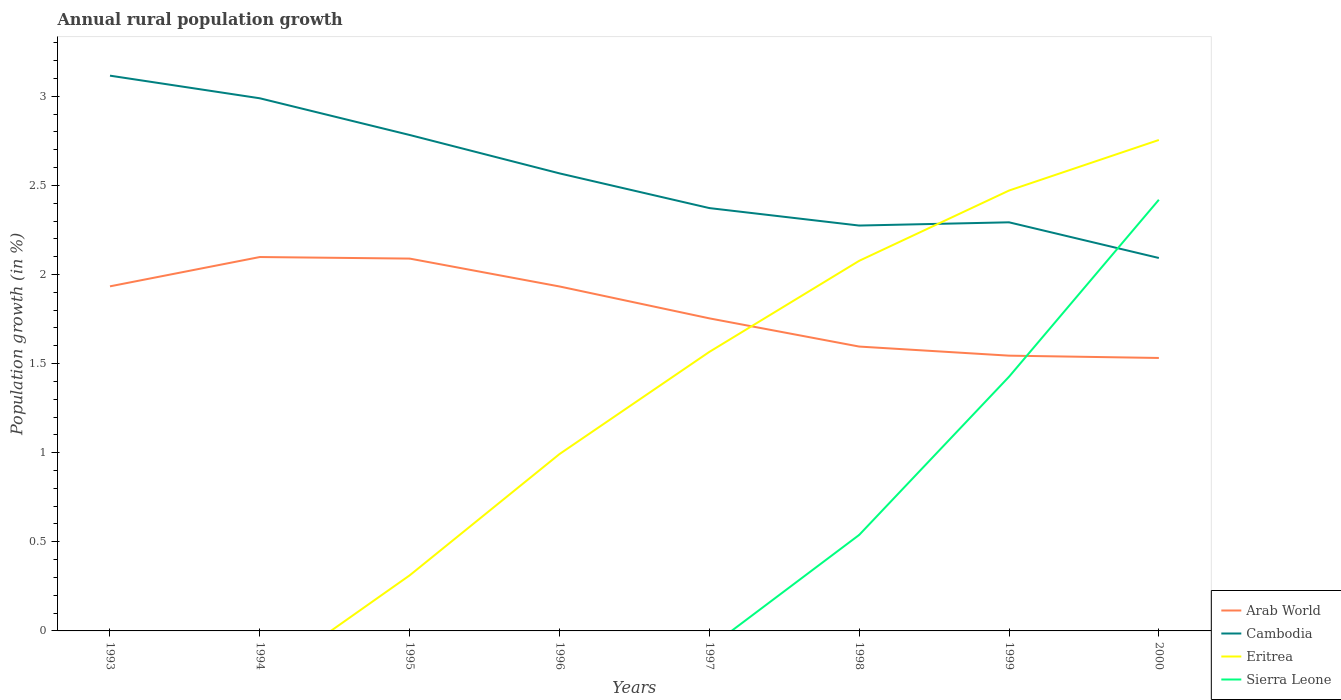How many different coloured lines are there?
Your answer should be compact. 4. Does the line corresponding to Arab World intersect with the line corresponding to Sierra Leone?
Your response must be concise. Yes. Is the number of lines equal to the number of legend labels?
Keep it short and to the point. No. Across all years, what is the maximum percentage of rural population growth in Sierra Leone?
Your answer should be very brief. 0. What is the total percentage of rural population growth in Arab World in the graph?
Your answer should be compact. 0.05. What is the difference between the highest and the second highest percentage of rural population growth in Sierra Leone?
Your response must be concise. 2.42. Is the percentage of rural population growth in Arab World strictly greater than the percentage of rural population growth in Sierra Leone over the years?
Give a very brief answer. No. How many years are there in the graph?
Make the answer very short. 8. What is the difference between two consecutive major ticks on the Y-axis?
Make the answer very short. 0.5. Does the graph contain any zero values?
Make the answer very short. Yes. Does the graph contain grids?
Keep it short and to the point. No. How many legend labels are there?
Give a very brief answer. 4. How are the legend labels stacked?
Your response must be concise. Vertical. What is the title of the graph?
Your answer should be compact. Annual rural population growth. What is the label or title of the Y-axis?
Ensure brevity in your answer.  Population growth (in %). What is the Population growth (in %) in Arab World in 1993?
Offer a very short reply. 1.93. What is the Population growth (in %) of Cambodia in 1993?
Provide a succinct answer. 3.12. What is the Population growth (in %) of Eritrea in 1993?
Your response must be concise. 0. What is the Population growth (in %) in Arab World in 1994?
Ensure brevity in your answer.  2.1. What is the Population growth (in %) of Cambodia in 1994?
Offer a terse response. 2.99. What is the Population growth (in %) in Sierra Leone in 1994?
Give a very brief answer. 0. What is the Population growth (in %) of Arab World in 1995?
Offer a terse response. 2.09. What is the Population growth (in %) of Cambodia in 1995?
Provide a short and direct response. 2.78. What is the Population growth (in %) of Eritrea in 1995?
Provide a short and direct response. 0.31. What is the Population growth (in %) of Sierra Leone in 1995?
Provide a succinct answer. 0. What is the Population growth (in %) in Arab World in 1996?
Keep it short and to the point. 1.93. What is the Population growth (in %) in Cambodia in 1996?
Give a very brief answer. 2.57. What is the Population growth (in %) in Eritrea in 1996?
Ensure brevity in your answer.  0.99. What is the Population growth (in %) of Arab World in 1997?
Provide a succinct answer. 1.75. What is the Population growth (in %) of Cambodia in 1997?
Give a very brief answer. 2.37. What is the Population growth (in %) in Eritrea in 1997?
Provide a succinct answer. 1.57. What is the Population growth (in %) of Arab World in 1998?
Provide a short and direct response. 1.6. What is the Population growth (in %) of Cambodia in 1998?
Make the answer very short. 2.27. What is the Population growth (in %) in Eritrea in 1998?
Make the answer very short. 2.08. What is the Population growth (in %) of Sierra Leone in 1998?
Offer a terse response. 0.54. What is the Population growth (in %) of Arab World in 1999?
Ensure brevity in your answer.  1.54. What is the Population growth (in %) of Cambodia in 1999?
Offer a terse response. 2.29. What is the Population growth (in %) of Eritrea in 1999?
Provide a succinct answer. 2.47. What is the Population growth (in %) in Sierra Leone in 1999?
Offer a very short reply. 1.43. What is the Population growth (in %) in Arab World in 2000?
Offer a very short reply. 1.53. What is the Population growth (in %) of Cambodia in 2000?
Offer a very short reply. 2.09. What is the Population growth (in %) in Eritrea in 2000?
Provide a short and direct response. 2.75. What is the Population growth (in %) of Sierra Leone in 2000?
Provide a succinct answer. 2.42. Across all years, what is the maximum Population growth (in %) of Arab World?
Offer a very short reply. 2.1. Across all years, what is the maximum Population growth (in %) of Cambodia?
Your answer should be compact. 3.12. Across all years, what is the maximum Population growth (in %) of Eritrea?
Offer a very short reply. 2.75. Across all years, what is the maximum Population growth (in %) of Sierra Leone?
Ensure brevity in your answer.  2.42. Across all years, what is the minimum Population growth (in %) in Arab World?
Provide a succinct answer. 1.53. Across all years, what is the minimum Population growth (in %) of Cambodia?
Provide a succinct answer. 2.09. Across all years, what is the minimum Population growth (in %) of Eritrea?
Make the answer very short. 0. Across all years, what is the minimum Population growth (in %) in Sierra Leone?
Your answer should be compact. 0. What is the total Population growth (in %) of Arab World in the graph?
Ensure brevity in your answer.  14.48. What is the total Population growth (in %) of Cambodia in the graph?
Offer a terse response. 20.49. What is the total Population growth (in %) of Eritrea in the graph?
Make the answer very short. 10.17. What is the total Population growth (in %) of Sierra Leone in the graph?
Offer a terse response. 4.38. What is the difference between the Population growth (in %) of Arab World in 1993 and that in 1994?
Provide a succinct answer. -0.16. What is the difference between the Population growth (in %) of Cambodia in 1993 and that in 1994?
Offer a very short reply. 0.13. What is the difference between the Population growth (in %) of Arab World in 1993 and that in 1995?
Keep it short and to the point. -0.16. What is the difference between the Population growth (in %) in Cambodia in 1993 and that in 1995?
Make the answer very short. 0.33. What is the difference between the Population growth (in %) of Arab World in 1993 and that in 1996?
Make the answer very short. 0. What is the difference between the Population growth (in %) in Cambodia in 1993 and that in 1996?
Keep it short and to the point. 0.55. What is the difference between the Population growth (in %) of Arab World in 1993 and that in 1997?
Your answer should be very brief. 0.18. What is the difference between the Population growth (in %) in Cambodia in 1993 and that in 1997?
Offer a terse response. 0.74. What is the difference between the Population growth (in %) in Arab World in 1993 and that in 1998?
Make the answer very short. 0.34. What is the difference between the Population growth (in %) of Cambodia in 1993 and that in 1998?
Ensure brevity in your answer.  0.84. What is the difference between the Population growth (in %) in Arab World in 1993 and that in 1999?
Your answer should be compact. 0.39. What is the difference between the Population growth (in %) in Cambodia in 1993 and that in 1999?
Your response must be concise. 0.82. What is the difference between the Population growth (in %) in Arab World in 1993 and that in 2000?
Make the answer very short. 0.4. What is the difference between the Population growth (in %) of Cambodia in 1993 and that in 2000?
Ensure brevity in your answer.  1.02. What is the difference between the Population growth (in %) of Arab World in 1994 and that in 1995?
Your response must be concise. 0.01. What is the difference between the Population growth (in %) in Cambodia in 1994 and that in 1995?
Your answer should be very brief. 0.21. What is the difference between the Population growth (in %) in Arab World in 1994 and that in 1996?
Your answer should be very brief. 0.17. What is the difference between the Population growth (in %) of Cambodia in 1994 and that in 1996?
Ensure brevity in your answer.  0.42. What is the difference between the Population growth (in %) in Arab World in 1994 and that in 1997?
Offer a terse response. 0.34. What is the difference between the Population growth (in %) in Cambodia in 1994 and that in 1997?
Your response must be concise. 0.62. What is the difference between the Population growth (in %) of Arab World in 1994 and that in 1998?
Provide a succinct answer. 0.5. What is the difference between the Population growth (in %) in Cambodia in 1994 and that in 1998?
Ensure brevity in your answer.  0.71. What is the difference between the Population growth (in %) in Arab World in 1994 and that in 1999?
Your answer should be very brief. 0.55. What is the difference between the Population growth (in %) in Cambodia in 1994 and that in 1999?
Your answer should be very brief. 0.7. What is the difference between the Population growth (in %) of Arab World in 1994 and that in 2000?
Give a very brief answer. 0.57. What is the difference between the Population growth (in %) in Cambodia in 1994 and that in 2000?
Offer a terse response. 0.9. What is the difference between the Population growth (in %) of Arab World in 1995 and that in 1996?
Ensure brevity in your answer.  0.16. What is the difference between the Population growth (in %) of Cambodia in 1995 and that in 1996?
Offer a terse response. 0.22. What is the difference between the Population growth (in %) in Eritrea in 1995 and that in 1996?
Offer a terse response. -0.68. What is the difference between the Population growth (in %) of Arab World in 1995 and that in 1997?
Make the answer very short. 0.34. What is the difference between the Population growth (in %) of Cambodia in 1995 and that in 1997?
Your answer should be very brief. 0.41. What is the difference between the Population growth (in %) of Eritrea in 1995 and that in 1997?
Ensure brevity in your answer.  -1.25. What is the difference between the Population growth (in %) of Arab World in 1995 and that in 1998?
Provide a succinct answer. 0.49. What is the difference between the Population growth (in %) of Cambodia in 1995 and that in 1998?
Your response must be concise. 0.51. What is the difference between the Population growth (in %) of Eritrea in 1995 and that in 1998?
Keep it short and to the point. -1.76. What is the difference between the Population growth (in %) in Arab World in 1995 and that in 1999?
Offer a very short reply. 0.54. What is the difference between the Population growth (in %) of Cambodia in 1995 and that in 1999?
Your answer should be very brief. 0.49. What is the difference between the Population growth (in %) in Eritrea in 1995 and that in 1999?
Your answer should be very brief. -2.16. What is the difference between the Population growth (in %) of Arab World in 1995 and that in 2000?
Your answer should be very brief. 0.56. What is the difference between the Population growth (in %) in Cambodia in 1995 and that in 2000?
Offer a very short reply. 0.69. What is the difference between the Population growth (in %) of Eritrea in 1995 and that in 2000?
Offer a terse response. -2.44. What is the difference between the Population growth (in %) of Arab World in 1996 and that in 1997?
Provide a succinct answer. 0.18. What is the difference between the Population growth (in %) in Cambodia in 1996 and that in 1997?
Your answer should be compact. 0.19. What is the difference between the Population growth (in %) of Eritrea in 1996 and that in 1997?
Your response must be concise. -0.57. What is the difference between the Population growth (in %) in Arab World in 1996 and that in 1998?
Ensure brevity in your answer.  0.34. What is the difference between the Population growth (in %) of Cambodia in 1996 and that in 1998?
Keep it short and to the point. 0.29. What is the difference between the Population growth (in %) of Eritrea in 1996 and that in 1998?
Make the answer very short. -1.08. What is the difference between the Population growth (in %) of Arab World in 1996 and that in 1999?
Offer a very short reply. 0.39. What is the difference between the Population growth (in %) in Cambodia in 1996 and that in 1999?
Your answer should be compact. 0.27. What is the difference between the Population growth (in %) of Eritrea in 1996 and that in 1999?
Your response must be concise. -1.48. What is the difference between the Population growth (in %) in Arab World in 1996 and that in 2000?
Offer a very short reply. 0.4. What is the difference between the Population growth (in %) in Cambodia in 1996 and that in 2000?
Keep it short and to the point. 0.47. What is the difference between the Population growth (in %) of Eritrea in 1996 and that in 2000?
Offer a terse response. -1.76. What is the difference between the Population growth (in %) of Arab World in 1997 and that in 1998?
Keep it short and to the point. 0.16. What is the difference between the Population growth (in %) in Cambodia in 1997 and that in 1998?
Provide a succinct answer. 0.1. What is the difference between the Population growth (in %) in Eritrea in 1997 and that in 1998?
Ensure brevity in your answer.  -0.51. What is the difference between the Population growth (in %) of Arab World in 1997 and that in 1999?
Make the answer very short. 0.21. What is the difference between the Population growth (in %) of Cambodia in 1997 and that in 1999?
Make the answer very short. 0.08. What is the difference between the Population growth (in %) of Eritrea in 1997 and that in 1999?
Ensure brevity in your answer.  -0.91. What is the difference between the Population growth (in %) in Arab World in 1997 and that in 2000?
Provide a succinct answer. 0.22. What is the difference between the Population growth (in %) in Cambodia in 1997 and that in 2000?
Keep it short and to the point. 0.28. What is the difference between the Population growth (in %) of Eritrea in 1997 and that in 2000?
Provide a succinct answer. -1.19. What is the difference between the Population growth (in %) in Arab World in 1998 and that in 1999?
Provide a succinct answer. 0.05. What is the difference between the Population growth (in %) of Cambodia in 1998 and that in 1999?
Keep it short and to the point. -0.02. What is the difference between the Population growth (in %) of Eritrea in 1998 and that in 1999?
Ensure brevity in your answer.  -0.39. What is the difference between the Population growth (in %) of Sierra Leone in 1998 and that in 1999?
Ensure brevity in your answer.  -0.89. What is the difference between the Population growth (in %) in Arab World in 1998 and that in 2000?
Provide a succinct answer. 0.06. What is the difference between the Population growth (in %) of Cambodia in 1998 and that in 2000?
Make the answer very short. 0.18. What is the difference between the Population growth (in %) in Eritrea in 1998 and that in 2000?
Offer a very short reply. -0.68. What is the difference between the Population growth (in %) in Sierra Leone in 1998 and that in 2000?
Provide a succinct answer. -1.88. What is the difference between the Population growth (in %) in Arab World in 1999 and that in 2000?
Ensure brevity in your answer.  0.01. What is the difference between the Population growth (in %) in Cambodia in 1999 and that in 2000?
Provide a short and direct response. 0.2. What is the difference between the Population growth (in %) of Eritrea in 1999 and that in 2000?
Keep it short and to the point. -0.28. What is the difference between the Population growth (in %) in Sierra Leone in 1999 and that in 2000?
Your answer should be compact. -0.99. What is the difference between the Population growth (in %) of Arab World in 1993 and the Population growth (in %) of Cambodia in 1994?
Offer a terse response. -1.06. What is the difference between the Population growth (in %) in Arab World in 1993 and the Population growth (in %) in Cambodia in 1995?
Your answer should be very brief. -0.85. What is the difference between the Population growth (in %) in Arab World in 1993 and the Population growth (in %) in Eritrea in 1995?
Provide a succinct answer. 1.62. What is the difference between the Population growth (in %) in Cambodia in 1993 and the Population growth (in %) in Eritrea in 1995?
Your answer should be compact. 2.8. What is the difference between the Population growth (in %) in Arab World in 1993 and the Population growth (in %) in Cambodia in 1996?
Your response must be concise. -0.63. What is the difference between the Population growth (in %) in Arab World in 1993 and the Population growth (in %) in Eritrea in 1996?
Offer a terse response. 0.94. What is the difference between the Population growth (in %) of Cambodia in 1993 and the Population growth (in %) of Eritrea in 1996?
Offer a very short reply. 2.12. What is the difference between the Population growth (in %) in Arab World in 1993 and the Population growth (in %) in Cambodia in 1997?
Ensure brevity in your answer.  -0.44. What is the difference between the Population growth (in %) in Arab World in 1993 and the Population growth (in %) in Eritrea in 1997?
Keep it short and to the point. 0.37. What is the difference between the Population growth (in %) in Cambodia in 1993 and the Population growth (in %) in Eritrea in 1997?
Provide a succinct answer. 1.55. What is the difference between the Population growth (in %) of Arab World in 1993 and the Population growth (in %) of Cambodia in 1998?
Your answer should be very brief. -0.34. What is the difference between the Population growth (in %) of Arab World in 1993 and the Population growth (in %) of Eritrea in 1998?
Give a very brief answer. -0.14. What is the difference between the Population growth (in %) of Arab World in 1993 and the Population growth (in %) of Sierra Leone in 1998?
Give a very brief answer. 1.39. What is the difference between the Population growth (in %) in Cambodia in 1993 and the Population growth (in %) in Eritrea in 1998?
Keep it short and to the point. 1.04. What is the difference between the Population growth (in %) of Cambodia in 1993 and the Population growth (in %) of Sierra Leone in 1998?
Your answer should be compact. 2.58. What is the difference between the Population growth (in %) in Arab World in 1993 and the Population growth (in %) in Cambodia in 1999?
Keep it short and to the point. -0.36. What is the difference between the Population growth (in %) of Arab World in 1993 and the Population growth (in %) of Eritrea in 1999?
Provide a succinct answer. -0.54. What is the difference between the Population growth (in %) in Arab World in 1993 and the Population growth (in %) in Sierra Leone in 1999?
Make the answer very short. 0.51. What is the difference between the Population growth (in %) in Cambodia in 1993 and the Population growth (in %) in Eritrea in 1999?
Your answer should be compact. 0.64. What is the difference between the Population growth (in %) of Cambodia in 1993 and the Population growth (in %) of Sierra Leone in 1999?
Give a very brief answer. 1.69. What is the difference between the Population growth (in %) in Arab World in 1993 and the Population growth (in %) in Cambodia in 2000?
Your answer should be very brief. -0.16. What is the difference between the Population growth (in %) of Arab World in 1993 and the Population growth (in %) of Eritrea in 2000?
Give a very brief answer. -0.82. What is the difference between the Population growth (in %) of Arab World in 1993 and the Population growth (in %) of Sierra Leone in 2000?
Offer a terse response. -0.49. What is the difference between the Population growth (in %) of Cambodia in 1993 and the Population growth (in %) of Eritrea in 2000?
Make the answer very short. 0.36. What is the difference between the Population growth (in %) in Cambodia in 1993 and the Population growth (in %) in Sierra Leone in 2000?
Your response must be concise. 0.7. What is the difference between the Population growth (in %) in Arab World in 1994 and the Population growth (in %) in Cambodia in 1995?
Offer a terse response. -0.68. What is the difference between the Population growth (in %) in Arab World in 1994 and the Population growth (in %) in Eritrea in 1995?
Provide a succinct answer. 1.79. What is the difference between the Population growth (in %) of Cambodia in 1994 and the Population growth (in %) of Eritrea in 1995?
Ensure brevity in your answer.  2.68. What is the difference between the Population growth (in %) in Arab World in 1994 and the Population growth (in %) in Cambodia in 1996?
Make the answer very short. -0.47. What is the difference between the Population growth (in %) of Arab World in 1994 and the Population growth (in %) of Eritrea in 1996?
Provide a short and direct response. 1.11. What is the difference between the Population growth (in %) of Cambodia in 1994 and the Population growth (in %) of Eritrea in 1996?
Offer a very short reply. 2. What is the difference between the Population growth (in %) in Arab World in 1994 and the Population growth (in %) in Cambodia in 1997?
Your answer should be very brief. -0.27. What is the difference between the Population growth (in %) of Arab World in 1994 and the Population growth (in %) of Eritrea in 1997?
Keep it short and to the point. 0.53. What is the difference between the Population growth (in %) in Cambodia in 1994 and the Population growth (in %) in Eritrea in 1997?
Give a very brief answer. 1.42. What is the difference between the Population growth (in %) of Arab World in 1994 and the Population growth (in %) of Cambodia in 1998?
Make the answer very short. -0.18. What is the difference between the Population growth (in %) of Arab World in 1994 and the Population growth (in %) of Eritrea in 1998?
Your response must be concise. 0.02. What is the difference between the Population growth (in %) of Arab World in 1994 and the Population growth (in %) of Sierra Leone in 1998?
Your answer should be very brief. 1.56. What is the difference between the Population growth (in %) in Cambodia in 1994 and the Population growth (in %) in Eritrea in 1998?
Offer a very short reply. 0.91. What is the difference between the Population growth (in %) of Cambodia in 1994 and the Population growth (in %) of Sierra Leone in 1998?
Your answer should be compact. 2.45. What is the difference between the Population growth (in %) of Arab World in 1994 and the Population growth (in %) of Cambodia in 1999?
Provide a short and direct response. -0.19. What is the difference between the Population growth (in %) in Arab World in 1994 and the Population growth (in %) in Eritrea in 1999?
Make the answer very short. -0.37. What is the difference between the Population growth (in %) of Arab World in 1994 and the Population growth (in %) of Sierra Leone in 1999?
Your response must be concise. 0.67. What is the difference between the Population growth (in %) in Cambodia in 1994 and the Population growth (in %) in Eritrea in 1999?
Offer a terse response. 0.52. What is the difference between the Population growth (in %) in Cambodia in 1994 and the Population growth (in %) in Sierra Leone in 1999?
Your answer should be very brief. 1.56. What is the difference between the Population growth (in %) of Arab World in 1994 and the Population growth (in %) of Cambodia in 2000?
Offer a terse response. 0.01. What is the difference between the Population growth (in %) of Arab World in 1994 and the Population growth (in %) of Eritrea in 2000?
Offer a terse response. -0.66. What is the difference between the Population growth (in %) in Arab World in 1994 and the Population growth (in %) in Sierra Leone in 2000?
Ensure brevity in your answer.  -0.32. What is the difference between the Population growth (in %) of Cambodia in 1994 and the Population growth (in %) of Eritrea in 2000?
Your answer should be very brief. 0.23. What is the difference between the Population growth (in %) of Cambodia in 1994 and the Population growth (in %) of Sierra Leone in 2000?
Your answer should be compact. 0.57. What is the difference between the Population growth (in %) in Arab World in 1995 and the Population growth (in %) in Cambodia in 1996?
Keep it short and to the point. -0.48. What is the difference between the Population growth (in %) in Arab World in 1995 and the Population growth (in %) in Eritrea in 1996?
Offer a terse response. 1.1. What is the difference between the Population growth (in %) in Cambodia in 1995 and the Population growth (in %) in Eritrea in 1996?
Give a very brief answer. 1.79. What is the difference between the Population growth (in %) in Arab World in 1995 and the Population growth (in %) in Cambodia in 1997?
Provide a succinct answer. -0.28. What is the difference between the Population growth (in %) of Arab World in 1995 and the Population growth (in %) of Eritrea in 1997?
Offer a terse response. 0.52. What is the difference between the Population growth (in %) of Cambodia in 1995 and the Population growth (in %) of Eritrea in 1997?
Provide a short and direct response. 1.22. What is the difference between the Population growth (in %) in Arab World in 1995 and the Population growth (in %) in Cambodia in 1998?
Offer a very short reply. -0.19. What is the difference between the Population growth (in %) of Arab World in 1995 and the Population growth (in %) of Eritrea in 1998?
Give a very brief answer. 0.01. What is the difference between the Population growth (in %) of Arab World in 1995 and the Population growth (in %) of Sierra Leone in 1998?
Your answer should be compact. 1.55. What is the difference between the Population growth (in %) in Cambodia in 1995 and the Population growth (in %) in Eritrea in 1998?
Make the answer very short. 0.71. What is the difference between the Population growth (in %) of Cambodia in 1995 and the Population growth (in %) of Sierra Leone in 1998?
Your response must be concise. 2.24. What is the difference between the Population growth (in %) of Eritrea in 1995 and the Population growth (in %) of Sierra Leone in 1998?
Make the answer very short. -0.23. What is the difference between the Population growth (in %) of Arab World in 1995 and the Population growth (in %) of Cambodia in 1999?
Your answer should be compact. -0.2. What is the difference between the Population growth (in %) in Arab World in 1995 and the Population growth (in %) in Eritrea in 1999?
Offer a terse response. -0.38. What is the difference between the Population growth (in %) in Arab World in 1995 and the Population growth (in %) in Sierra Leone in 1999?
Your answer should be compact. 0.66. What is the difference between the Population growth (in %) of Cambodia in 1995 and the Population growth (in %) of Eritrea in 1999?
Offer a very short reply. 0.31. What is the difference between the Population growth (in %) of Cambodia in 1995 and the Population growth (in %) of Sierra Leone in 1999?
Offer a very short reply. 1.36. What is the difference between the Population growth (in %) of Eritrea in 1995 and the Population growth (in %) of Sierra Leone in 1999?
Offer a terse response. -1.11. What is the difference between the Population growth (in %) in Arab World in 1995 and the Population growth (in %) in Cambodia in 2000?
Give a very brief answer. -0. What is the difference between the Population growth (in %) of Arab World in 1995 and the Population growth (in %) of Eritrea in 2000?
Offer a very short reply. -0.67. What is the difference between the Population growth (in %) of Arab World in 1995 and the Population growth (in %) of Sierra Leone in 2000?
Make the answer very short. -0.33. What is the difference between the Population growth (in %) in Cambodia in 1995 and the Population growth (in %) in Eritrea in 2000?
Provide a short and direct response. 0.03. What is the difference between the Population growth (in %) in Cambodia in 1995 and the Population growth (in %) in Sierra Leone in 2000?
Your answer should be very brief. 0.36. What is the difference between the Population growth (in %) in Eritrea in 1995 and the Population growth (in %) in Sierra Leone in 2000?
Offer a very short reply. -2.11. What is the difference between the Population growth (in %) of Arab World in 1996 and the Population growth (in %) of Cambodia in 1997?
Make the answer very short. -0.44. What is the difference between the Population growth (in %) in Arab World in 1996 and the Population growth (in %) in Eritrea in 1997?
Offer a terse response. 0.37. What is the difference between the Population growth (in %) of Arab World in 1996 and the Population growth (in %) of Cambodia in 1998?
Offer a terse response. -0.34. What is the difference between the Population growth (in %) in Arab World in 1996 and the Population growth (in %) in Eritrea in 1998?
Ensure brevity in your answer.  -0.14. What is the difference between the Population growth (in %) of Arab World in 1996 and the Population growth (in %) of Sierra Leone in 1998?
Your answer should be compact. 1.39. What is the difference between the Population growth (in %) in Cambodia in 1996 and the Population growth (in %) in Eritrea in 1998?
Make the answer very short. 0.49. What is the difference between the Population growth (in %) in Cambodia in 1996 and the Population growth (in %) in Sierra Leone in 1998?
Your response must be concise. 2.03. What is the difference between the Population growth (in %) in Eritrea in 1996 and the Population growth (in %) in Sierra Leone in 1998?
Offer a very short reply. 0.45. What is the difference between the Population growth (in %) in Arab World in 1996 and the Population growth (in %) in Cambodia in 1999?
Your answer should be compact. -0.36. What is the difference between the Population growth (in %) in Arab World in 1996 and the Population growth (in %) in Eritrea in 1999?
Make the answer very short. -0.54. What is the difference between the Population growth (in %) in Arab World in 1996 and the Population growth (in %) in Sierra Leone in 1999?
Provide a succinct answer. 0.51. What is the difference between the Population growth (in %) of Cambodia in 1996 and the Population growth (in %) of Eritrea in 1999?
Offer a very short reply. 0.1. What is the difference between the Population growth (in %) of Cambodia in 1996 and the Population growth (in %) of Sierra Leone in 1999?
Keep it short and to the point. 1.14. What is the difference between the Population growth (in %) in Eritrea in 1996 and the Population growth (in %) in Sierra Leone in 1999?
Your answer should be very brief. -0.43. What is the difference between the Population growth (in %) in Arab World in 1996 and the Population growth (in %) in Cambodia in 2000?
Your answer should be very brief. -0.16. What is the difference between the Population growth (in %) of Arab World in 1996 and the Population growth (in %) of Eritrea in 2000?
Offer a very short reply. -0.82. What is the difference between the Population growth (in %) of Arab World in 1996 and the Population growth (in %) of Sierra Leone in 2000?
Offer a very short reply. -0.49. What is the difference between the Population growth (in %) in Cambodia in 1996 and the Population growth (in %) in Eritrea in 2000?
Offer a terse response. -0.19. What is the difference between the Population growth (in %) of Cambodia in 1996 and the Population growth (in %) of Sierra Leone in 2000?
Offer a terse response. 0.15. What is the difference between the Population growth (in %) of Eritrea in 1996 and the Population growth (in %) of Sierra Leone in 2000?
Give a very brief answer. -1.43. What is the difference between the Population growth (in %) of Arab World in 1997 and the Population growth (in %) of Cambodia in 1998?
Provide a short and direct response. -0.52. What is the difference between the Population growth (in %) in Arab World in 1997 and the Population growth (in %) in Eritrea in 1998?
Your answer should be very brief. -0.32. What is the difference between the Population growth (in %) in Arab World in 1997 and the Population growth (in %) in Sierra Leone in 1998?
Make the answer very short. 1.22. What is the difference between the Population growth (in %) of Cambodia in 1997 and the Population growth (in %) of Eritrea in 1998?
Your answer should be compact. 0.3. What is the difference between the Population growth (in %) in Cambodia in 1997 and the Population growth (in %) in Sierra Leone in 1998?
Ensure brevity in your answer.  1.83. What is the difference between the Population growth (in %) in Eritrea in 1997 and the Population growth (in %) in Sierra Leone in 1998?
Offer a very short reply. 1.03. What is the difference between the Population growth (in %) of Arab World in 1997 and the Population growth (in %) of Cambodia in 1999?
Provide a succinct answer. -0.54. What is the difference between the Population growth (in %) in Arab World in 1997 and the Population growth (in %) in Eritrea in 1999?
Provide a short and direct response. -0.72. What is the difference between the Population growth (in %) of Arab World in 1997 and the Population growth (in %) of Sierra Leone in 1999?
Provide a short and direct response. 0.33. What is the difference between the Population growth (in %) of Cambodia in 1997 and the Population growth (in %) of Eritrea in 1999?
Your answer should be compact. -0.1. What is the difference between the Population growth (in %) in Cambodia in 1997 and the Population growth (in %) in Sierra Leone in 1999?
Your answer should be compact. 0.95. What is the difference between the Population growth (in %) in Eritrea in 1997 and the Population growth (in %) in Sierra Leone in 1999?
Give a very brief answer. 0.14. What is the difference between the Population growth (in %) in Arab World in 1997 and the Population growth (in %) in Cambodia in 2000?
Your answer should be compact. -0.34. What is the difference between the Population growth (in %) in Arab World in 1997 and the Population growth (in %) in Eritrea in 2000?
Ensure brevity in your answer.  -1. What is the difference between the Population growth (in %) in Arab World in 1997 and the Population growth (in %) in Sierra Leone in 2000?
Ensure brevity in your answer.  -0.67. What is the difference between the Population growth (in %) of Cambodia in 1997 and the Population growth (in %) of Eritrea in 2000?
Offer a very short reply. -0.38. What is the difference between the Population growth (in %) in Cambodia in 1997 and the Population growth (in %) in Sierra Leone in 2000?
Make the answer very short. -0.05. What is the difference between the Population growth (in %) in Eritrea in 1997 and the Population growth (in %) in Sierra Leone in 2000?
Your response must be concise. -0.85. What is the difference between the Population growth (in %) in Arab World in 1998 and the Population growth (in %) in Cambodia in 1999?
Give a very brief answer. -0.7. What is the difference between the Population growth (in %) of Arab World in 1998 and the Population growth (in %) of Eritrea in 1999?
Make the answer very short. -0.88. What is the difference between the Population growth (in %) in Arab World in 1998 and the Population growth (in %) in Sierra Leone in 1999?
Ensure brevity in your answer.  0.17. What is the difference between the Population growth (in %) in Cambodia in 1998 and the Population growth (in %) in Eritrea in 1999?
Your answer should be very brief. -0.2. What is the difference between the Population growth (in %) of Cambodia in 1998 and the Population growth (in %) of Sierra Leone in 1999?
Offer a very short reply. 0.85. What is the difference between the Population growth (in %) of Eritrea in 1998 and the Population growth (in %) of Sierra Leone in 1999?
Your answer should be compact. 0.65. What is the difference between the Population growth (in %) of Arab World in 1998 and the Population growth (in %) of Cambodia in 2000?
Provide a short and direct response. -0.5. What is the difference between the Population growth (in %) of Arab World in 1998 and the Population growth (in %) of Eritrea in 2000?
Offer a very short reply. -1.16. What is the difference between the Population growth (in %) of Arab World in 1998 and the Population growth (in %) of Sierra Leone in 2000?
Offer a terse response. -0.82. What is the difference between the Population growth (in %) of Cambodia in 1998 and the Population growth (in %) of Eritrea in 2000?
Provide a succinct answer. -0.48. What is the difference between the Population growth (in %) in Cambodia in 1998 and the Population growth (in %) in Sierra Leone in 2000?
Give a very brief answer. -0.14. What is the difference between the Population growth (in %) in Eritrea in 1998 and the Population growth (in %) in Sierra Leone in 2000?
Provide a succinct answer. -0.34. What is the difference between the Population growth (in %) of Arab World in 1999 and the Population growth (in %) of Cambodia in 2000?
Give a very brief answer. -0.55. What is the difference between the Population growth (in %) in Arab World in 1999 and the Population growth (in %) in Eritrea in 2000?
Offer a terse response. -1.21. What is the difference between the Population growth (in %) of Arab World in 1999 and the Population growth (in %) of Sierra Leone in 2000?
Ensure brevity in your answer.  -0.87. What is the difference between the Population growth (in %) in Cambodia in 1999 and the Population growth (in %) in Eritrea in 2000?
Make the answer very short. -0.46. What is the difference between the Population growth (in %) of Cambodia in 1999 and the Population growth (in %) of Sierra Leone in 2000?
Provide a succinct answer. -0.13. What is the difference between the Population growth (in %) of Eritrea in 1999 and the Population growth (in %) of Sierra Leone in 2000?
Give a very brief answer. 0.05. What is the average Population growth (in %) of Arab World per year?
Your answer should be compact. 1.81. What is the average Population growth (in %) in Cambodia per year?
Offer a terse response. 2.56. What is the average Population growth (in %) in Eritrea per year?
Your response must be concise. 1.27. What is the average Population growth (in %) in Sierra Leone per year?
Your response must be concise. 0.55. In the year 1993, what is the difference between the Population growth (in %) in Arab World and Population growth (in %) in Cambodia?
Ensure brevity in your answer.  -1.18. In the year 1994, what is the difference between the Population growth (in %) in Arab World and Population growth (in %) in Cambodia?
Keep it short and to the point. -0.89. In the year 1995, what is the difference between the Population growth (in %) of Arab World and Population growth (in %) of Cambodia?
Ensure brevity in your answer.  -0.69. In the year 1995, what is the difference between the Population growth (in %) in Arab World and Population growth (in %) in Eritrea?
Your response must be concise. 1.78. In the year 1995, what is the difference between the Population growth (in %) in Cambodia and Population growth (in %) in Eritrea?
Offer a very short reply. 2.47. In the year 1996, what is the difference between the Population growth (in %) in Arab World and Population growth (in %) in Cambodia?
Make the answer very short. -0.63. In the year 1996, what is the difference between the Population growth (in %) of Arab World and Population growth (in %) of Eritrea?
Your answer should be very brief. 0.94. In the year 1996, what is the difference between the Population growth (in %) of Cambodia and Population growth (in %) of Eritrea?
Make the answer very short. 1.57. In the year 1997, what is the difference between the Population growth (in %) of Arab World and Population growth (in %) of Cambodia?
Your response must be concise. -0.62. In the year 1997, what is the difference between the Population growth (in %) in Arab World and Population growth (in %) in Eritrea?
Provide a succinct answer. 0.19. In the year 1997, what is the difference between the Population growth (in %) in Cambodia and Population growth (in %) in Eritrea?
Offer a terse response. 0.81. In the year 1998, what is the difference between the Population growth (in %) in Arab World and Population growth (in %) in Cambodia?
Ensure brevity in your answer.  -0.68. In the year 1998, what is the difference between the Population growth (in %) of Arab World and Population growth (in %) of Eritrea?
Make the answer very short. -0.48. In the year 1998, what is the difference between the Population growth (in %) in Arab World and Population growth (in %) in Sierra Leone?
Your response must be concise. 1.06. In the year 1998, what is the difference between the Population growth (in %) of Cambodia and Population growth (in %) of Eritrea?
Provide a short and direct response. 0.2. In the year 1998, what is the difference between the Population growth (in %) in Cambodia and Population growth (in %) in Sierra Leone?
Provide a short and direct response. 1.74. In the year 1998, what is the difference between the Population growth (in %) in Eritrea and Population growth (in %) in Sierra Leone?
Make the answer very short. 1.54. In the year 1999, what is the difference between the Population growth (in %) of Arab World and Population growth (in %) of Cambodia?
Provide a short and direct response. -0.75. In the year 1999, what is the difference between the Population growth (in %) in Arab World and Population growth (in %) in Eritrea?
Provide a succinct answer. -0.93. In the year 1999, what is the difference between the Population growth (in %) in Arab World and Population growth (in %) in Sierra Leone?
Ensure brevity in your answer.  0.12. In the year 1999, what is the difference between the Population growth (in %) of Cambodia and Population growth (in %) of Eritrea?
Keep it short and to the point. -0.18. In the year 1999, what is the difference between the Population growth (in %) in Cambodia and Population growth (in %) in Sierra Leone?
Keep it short and to the point. 0.87. In the year 1999, what is the difference between the Population growth (in %) of Eritrea and Population growth (in %) of Sierra Leone?
Your answer should be compact. 1.04. In the year 2000, what is the difference between the Population growth (in %) of Arab World and Population growth (in %) of Cambodia?
Your answer should be very brief. -0.56. In the year 2000, what is the difference between the Population growth (in %) of Arab World and Population growth (in %) of Eritrea?
Your answer should be compact. -1.22. In the year 2000, what is the difference between the Population growth (in %) of Arab World and Population growth (in %) of Sierra Leone?
Provide a short and direct response. -0.89. In the year 2000, what is the difference between the Population growth (in %) of Cambodia and Population growth (in %) of Eritrea?
Provide a succinct answer. -0.66. In the year 2000, what is the difference between the Population growth (in %) in Cambodia and Population growth (in %) in Sierra Leone?
Your answer should be compact. -0.33. In the year 2000, what is the difference between the Population growth (in %) in Eritrea and Population growth (in %) in Sierra Leone?
Provide a short and direct response. 0.34. What is the ratio of the Population growth (in %) of Arab World in 1993 to that in 1994?
Provide a succinct answer. 0.92. What is the ratio of the Population growth (in %) of Cambodia in 1993 to that in 1994?
Your answer should be compact. 1.04. What is the ratio of the Population growth (in %) of Arab World in 1993 to that in 1995?
Make the answer very short. 0.93. What is the ratio of the Population growth (in %) of Cambodia in 1993 to that in 1995?
Offer a very short reply. 1.12. What is the ratio of the Population growth (in %) of Cambodia in 1993 to that in 1996?
Keep it short and to the point. 1.21. What is the ratio of the Population growth (in %) of Arab World in 1993 to that in 1997?
Provide a short and direct response. 1.1. What is the ratio of the Population growth (in %) in Cambodia in 1993 to that in 1997?
Provide a succinct answer. 1.31. What is the ratio of the Population growth (in %) in Arab World in 1993 to that in 1998?
Your answer should be compact. 1.21. What is the ratio of the Population growth (in %) of Cambodia in 1993 to that in 1998?
Provide a short and direct response. 1.37. What is the ratio of the Population growth (in %) of Arab World in 1993 to that in 1999?
Your answer should be compact. 1.25. What is the ratio of the Population growth (in %) in Cambodia in 1993 to that in 1999?
Offer a very short reply. 1.36. What is the ratio of the Population growth (in %) in Arab World in 1993 to that in 2000?
Your answer should be compact. 1.26. What is the ratio of the Population growth (in %) in Cambodia in 1993 to that in 2000?
Make the answer very short. 1.49. What is the ratio of the Population growth (in %) in Arab World in 1994 to that in 1995?
Provide a succinct answer. 1. What is the ratio of the Population growth (in %) of Cambodia in 1994 to that in 1995?
Keep it short and to the point. 1.07. What is the ratio of the Population growth (in %) in Arab World in 1994 to that in 1996?
Provide a short and direct response. 1.09. What is the ratio of the Population growth (in %) of Cambodia in 1994 to that in 1996?
Provide a short and direct response. 1.16. What is the ratio of the Population growth (in %) of Arab World in 1994 to that in 1997?
Your answer should be compact. 1.2. What is the ratio of the Population growth (in %) in Cambodia in 1994 to that in 1997?
Give a very brief answer. 1.26. What is the ratio of the Population growth (in %) of Arab World in 1994 to that in 1998?
Your answer should be compact. 1.31. What is the ratio of the Population growth (in %) in Cambodia in 1994 to that in 1998?
Provide a short and direct response. 1.31. What is the ratio of the Population growth (in %) of Arab World in 1994 to that in 1999?
Ensure brevity in your answer.  1.36. What is the ratio of the Population growth (in %) of Cambodia in 1994 to that in 1999?
Provide a succinct answer. 1.3. What is the ratio of the Population growth (in %) of Arab World in 1994 to that in 2000?
Ensure brevity in your answer.  1.37. What is the ratio of the Population growth (in %) of Cambodia in 1994 to that in 2000?
Make the answer very short. 1.43. What is the ratio of the Population growth (in %) of Arab World in 1995 to that in 1996?
Give a very brief answer. 1.08. What is the ratio of the Population growth (in %) in Cambodia in 1995 to that in 1996?
Make the answer very short. 1.08. What is the ratio of the Population growth (in %) of Eritrea in 1995 to that in 1996?
Give a very brief answer. 0.31. What is the ratio of the Population growth (in %) of Arab World in 1995 to that in 1997?
Your answer should be very brief. 1.19. What is the ratio of the Population growth (in %) in Cambodia in 1995 to that in 1997?
Your answer should be compact. 1.17. What is the ratio of the Population growth (in %) of Eritrea in 1995 to that in 1997?
Give a very brief answer. 0.2. What is the ratio of the Population growth (in %) in Arab World in 1995 to that in 1998?
Make the answer very short. 1.31. What is the ratio of the Population growth (in %) in Cambodia in 1995 to that in 1998?
Keep it short and to the point. 1.22. What is the ratio of the Population growth (in %) of Eritrea in 1995 to that in 1998?
Make the answer very short. 0.15. What is the ratio of the Population growth (in %) of Arab World in 1995 to that in 1999?
Provide a short and direct response. 1.35. What is the ratio of the Population growth (in %) of Cambodia in 1995 to that in 1999?
Your answer should be very brief. 1.21. What is the ratio of the Population growth (in %) of Eritrea in 1995 to that in 1999?
Your response must be concise. 0.13. What is the ratio of the Population growth (in %) in Arab World in 1995 to that in 2000?
Offer a very short reply. 1.36. What is the ratio of the Population growth (in %) in Cambodia in 1995 to that in 2000?
Make the answer very short. 1.33. What is the ratio of the Population growth (in %) of Eritrea in 1995 to that in 2000?
Make the answer very short. 0.11. What is the ratio of the Population growth (in %) of Arab World in 1996 to that in 1997?
Your response must be concise. 1.1. What is the ratio of the Population growth (in %) in Cambodia in 1996 to that in 1997?
Ensure brevity in your answer.  1.08. What is the ratio of the Population growth (in %) of Eritrea in 1996 to that in 1997?
Your answer should be very brief. 0.63. What is the ratio of the Population growth (in %) of Arab World in 1996 to that in 1998?
Provide a short and direct response. 1.21. What is the ratio of the Population growth (in %) of Cambodia in 1996 to that in 1998?
Your answer should be compact. 1.13. What is the ratio of the Population growth (in %) in Eritrea in 1996 to that in 1998?
Keep it short and to the point. 0.48. What is the ratio of the Population growth (in %) in Arab World in 1996 to that in 1999?
Ensure brevity in your answer.  1.25. What is the ratio of the Population growth (in %) in Cambodia in 1996 to that in 1999?
Your answer should be very brief. 1.12. What is the ratio of the Population growth (in %) of Eritrea in 1996 to that in 1999?
Your answer should be compact. 0.4. What is the ratio of the Population growth (in %) of Arab World in 1996 to that in 2000?
Your answer should be compact. 1.26. What is the ratio of the Population growth (in %) of Cambodia in 1996 to that in 2000?
Provide a short and direct response. 1.23. What is the ratio of the Population growth (in %) in Eritrea in 1996 to that in 2000?
Offer a very short reply. 0.36. What is the ratio of the Population growth (in %) of Arab World in 1997 to that in 1998?
Offer a terse response. 1.1. What is the ratio of the Population growth (in %) in Cambodia in 1997 to that in 1998?
Your response must be concise. 1.04. What is the ratio of the Population growth (in %) in Eritrea in 1997 to that in 1998?
Your answer should be very brief. 0.75. What is the ratio of the Population growth (in %) of Arab World in 1997 to that in 1999?
Make the answer very short. 1.14. What is the ratio of the Population growth (in %) of Cambodia in 1997 to that in 1999?
Your answer should be compact. 1.03. What is the ratio of the Population growth (in %) of Eritrea in 1997 to that in 1999?
Ensure brevity in your answer.  0.63. What is the ratio of the Population growth (in %) of Arab World in 1997 to that in 2000?
Your answer should be very brief. 1.15. What is the ratio of the Population growth (in %) in Cambodia in 1997 to that in 2000?
Your answer should be very brief. 1.13. What is the ratio of the Population growth (in %) in Eritrea in 1997 to that in 2000?
Make the answer very short. 0.57. What is the ratio of the Population growth (in %) of Arab World in 1998 to that in 1999?
Provide a short and direct response. 1.03. What is the ratio of the Population growth (in %) in Eritrea in 1998 to that in 1999?
Your answer should be compact. 0.84. What is the ratio of the Population growth (in %) of Sierra Leone in 1998 to that in 1999?
Your response must be concise. 0.38. What is the ratio of the Population growth (in %) in Arab World in 1998 to that in 2000?
Offer a terse response. 1.04. What is the ratio of the Population growth (in %) of Cambodia in 1998 to that in 2000?
Your answer should be compact. 1.09. What is the ratio of the Population growth (in %) in Eritrea in 1998 to that in 2000?
Give a very brief answer. 0.75. What is the ratio of the Population growth (in %) of Sierra Leone in 1998 to that in 2000?
Provide a succinct answer. 0.22. What is the ratio of the Population growth (in %) in Arab World in 1999 to that in 2000?
Provide a short and direct response. 1.01. What is the ratio of the Population growth (in %) of Cambodia in 1999 to that in 2000?
Your answer should be very brief. 1.1. What is the ratio of the Population growth (in %) of Eritrea in 1999 to that in 2000?
Give a very brief answer. 0.9. What is the ratio of the Population growth (in %) in Sierra Leone in 1999 to that in 2000?
Provide a succinct answer. 0.59. What is the difference between the highest and the second highest Population growth (in %) in Arab World?
Your answer should be very brief. 0.01. What is the difference between the highest and the second highest Population growth (in %) in Cambodia?
Your answer should be compact. 0.13. What is the difference between the highest and the second highest Population growth (in %) of Eritrea?
Provide a succinct answer. 0.28. What is the difference between the highest and the lowest Population growth (in %) in Arab World?
Your response must be concise. 0.57. What is the difference between the highest and the lowest Population growth (in %) of Eritrea?
Your answer should be compact. 2.75. What is the difference between the highest and the lowest Population growth (in %) of Sierra Leone?
Keep it short and to the point. 2.42. 